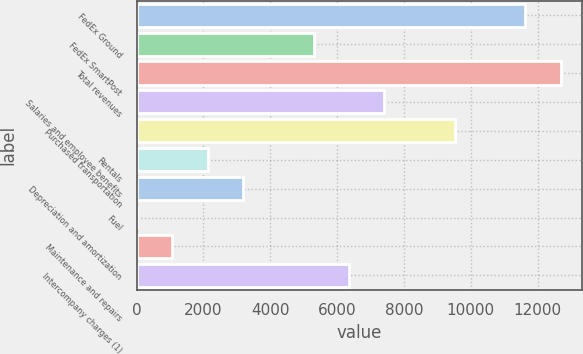Convert chart. <chart><loc_0><loc_0><loc_500><loc_500><bar_chart><fcel>FedEx Ground<fcel>FedEx SmartPost<fcel>Total revenues<fcel>Salaries and employee benefits<fcel>Purchased transportation<fcel>Rentals<fcel>Depreciation and amortization<fcel>Fuel<fcel>Maintenance and repairs<fcel>Intercompany charges (1)<nl><fcel>11634.1<fcel>5297.5<fcel>12690.2<fcel>7409.7<fcel>9521.9<fcel>2129.2<fcel>3185.3<fcel>17<fcel>1073.1<fcel>6353.6<nl></chart> 